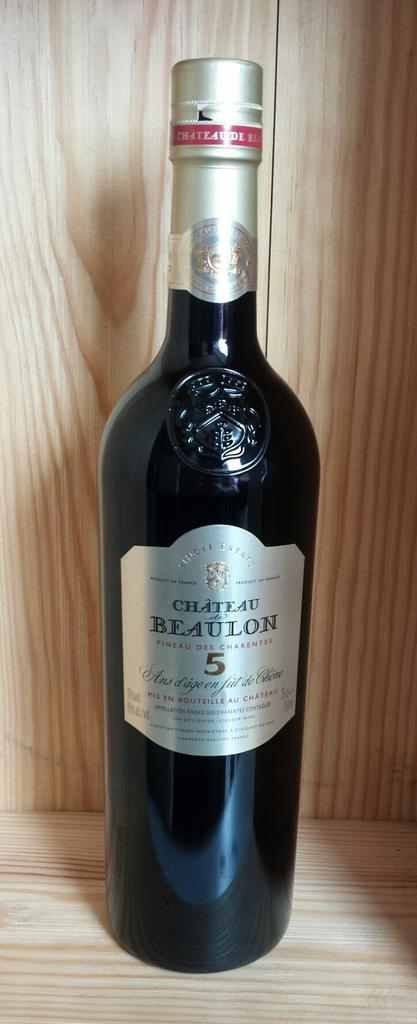<image>
Give a short and clear explanation of the subsequent image. A bottle of Chateau Beaulon wine sits unopened. 